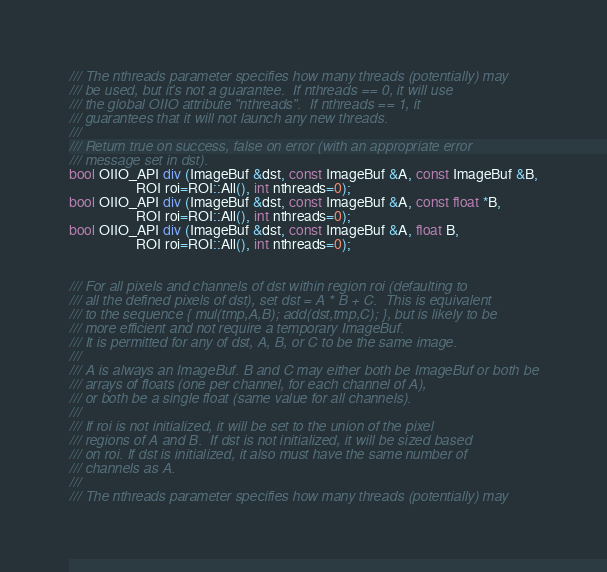<code> <loc_0><loc_0><loc_500><loc_500><_C_>/// The nthreads parameter specifies how many threads (potentially) may
/// be used, but it's not a guarantee.  If nthreads == 0, it will use
/// the global OIIO attribute "nthreads".  If nthreads == 1, it
/// guarantees that it will not launch any new threads.
///
/// Return true on success, false on error (with an appropriate error
/// message set in dst).
bool OIIO_API div (ImageBuf &dst, const ImageBuf &A, const ImageBuf &B,
                   ROI roi=ROI::All(), int nthreads=0);
bool OIIO_API div (ImageBuf &dst, const ImageBuf &A, const float *B,
                   ROI roi=ROI::All(), int nthreads=0);
bool OIIO_API div (ImageBuf &dst, const ImageBuf &A, float B,
                   ROI roi=ROI::All(), int nthreads=0);


/// For all pixels and channels of dst within region roi (defaulting to
/// all the defined pixels of dst), set dst = A * B + C.  This is equivalent
/// to the sequence { mul(tmp,A,B); add(dst,tmp,C); }, but is likely to be
/// more efficient and not require a temporary ImageBuf.
/// It is permitted for any of dst, A, B, or C to be the same image.
///
/// A is always an ImageBuf. B and C may either both be ImageBuf or both be
/// arrays of floats (one per channel, for each channel of A),
/// or both be a single float (same value for all channels).
///
/// If roi is not initialized, it will be set to the union of the pixel
/// regions of A and B.  If dst is not initialized, it will be sized based
/// on roi. If dst is initialized, it also must have the same number of
/// channels as A.
///
/// The nthreads parameter specifies how many threads (potentially) may</code> 